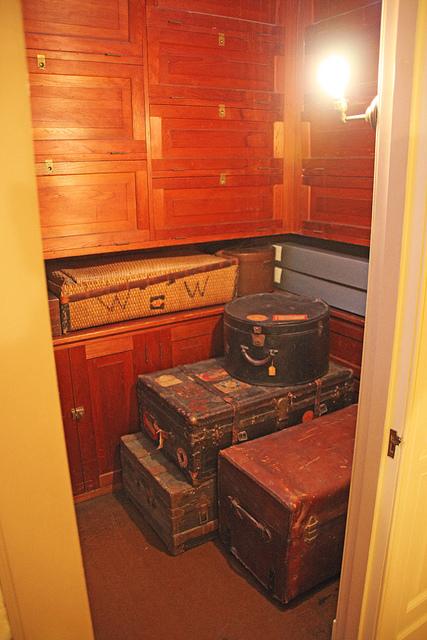What are the rectangular objects on the floor?
Be succinct. Trunks. Are the cabinets wooden?
Short answer required. Yes. How many cabinet locks are there?
Concise answer only. 6. 